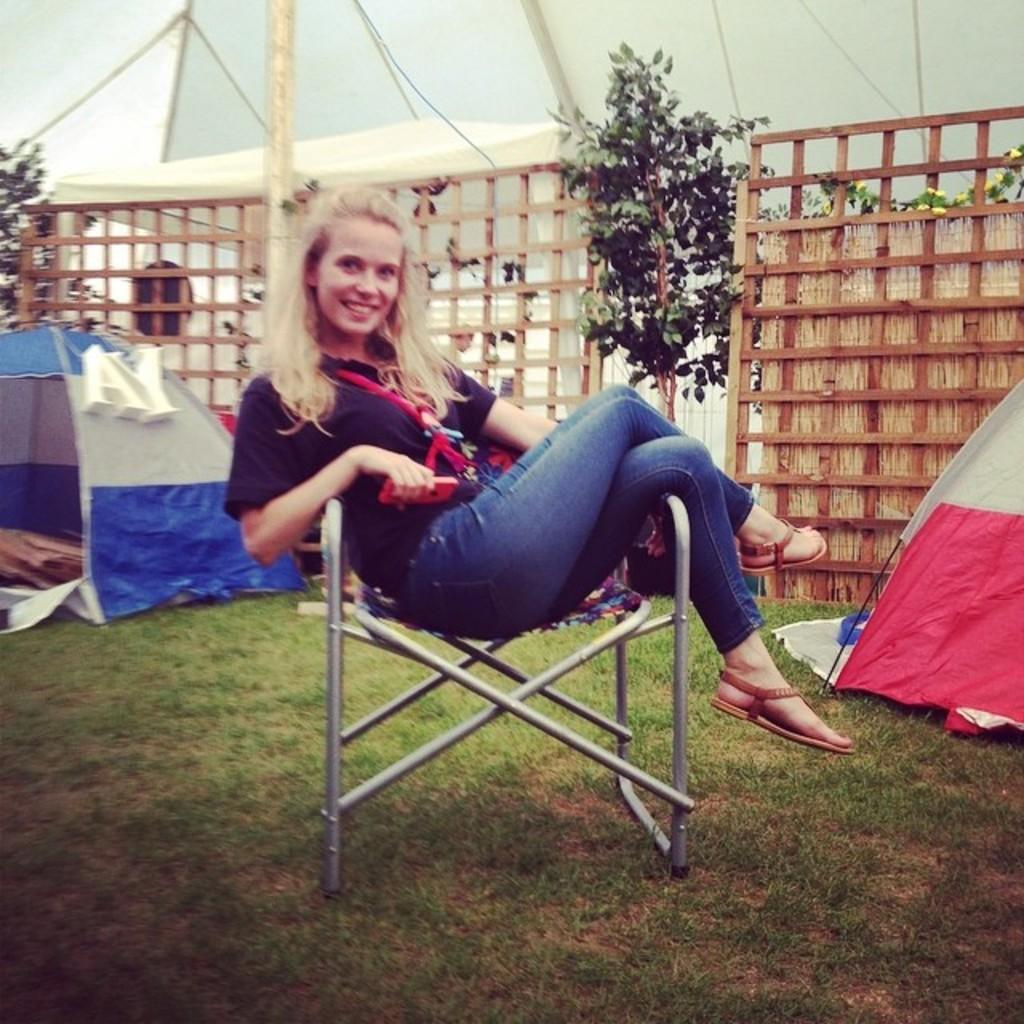Where was the image taken? The image was taken outdoors. What is the woman in the image wearing? The woman is wearing a black t-shirt. What is the woman doing in the image? The woman is sitting on a chair. What can be seen in the background of the image? There are tents, plants, and wooden fencing visible in the background. What type of division is present in the image? There is no division present in the image; it is a photograph of a woman sitting outdoors. 